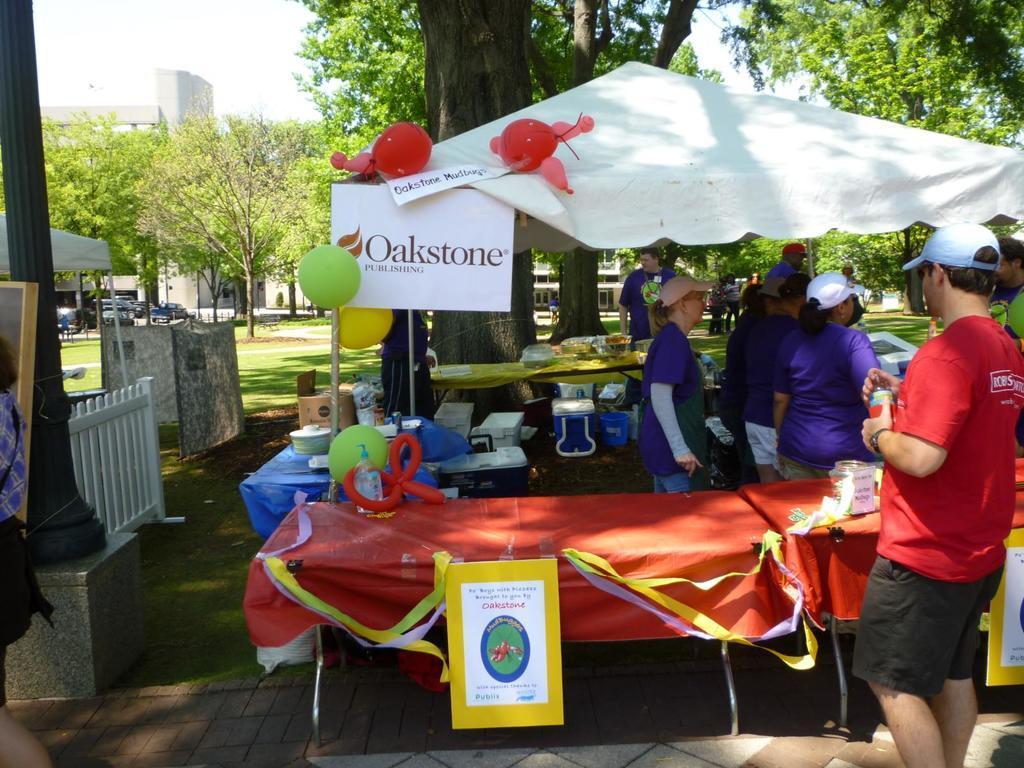Describe this image in one or two sentences. In this image there are tables on the grassland. There are few objects on the tables. There is a tent on the grassland. There is a poster attached to the table which is covered with a cloth. The table is decorated with the ribbons. Right side there is a person standing on the path. He is wearing a cap. He is holding an object. There are people standing on the grassland. Left side there is a person carrying a bag. Behind there is a board kept near the pole. Behind there is a fence. Behind the pole there is a tent. There are vehicles on the road. Background there are trees and buildings. Top of the image there is sky. There are balloons attached to the tent. 